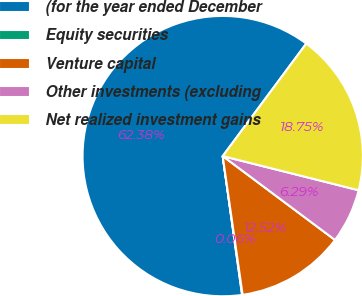Convert chart to OTSL. <chart><loc_0><loc_0><loc_500><loc_500><pie_chart><fcel>(for the year ended December<fcel>Equity securities<fcel>Venture capital<fcel>Other investments (excluding<fcel>Net realized investment gains<nl><fcel>62.37%<fcel>0.06%<fcel>12.52%<fcel>6.29%<fcel>18.75%<nl></chart> 